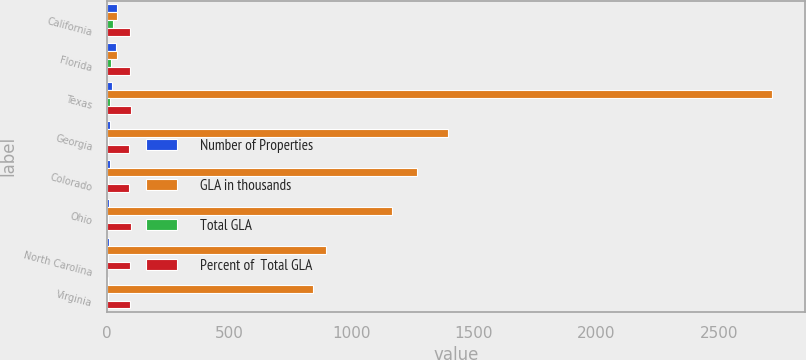<chart> <loc_0><loc_0><loc_500><loc_500><stacked_bar_chart><ecel><fcel>California<fcel>Florida<fcel>Texas<fcel>Georgia<fcel>Colorado<fcel>Ohio<fcel>North Carolina<fcel>Virginia<nl><fcel>Number of Properties<fcel>42<fcel>39<fcel>22<fcel>15<fcel>15<fcel>8<fcel>10<fcel>6<nl><fcel>GLA in thousands<fcel>40.5<fcel>40.5<fcel>2716<fcel>1392<fcel>1266<fcel>1164<fcel>895<fcel>841<nl><fcel>Total GLA<fcel>24.1<fcel>18.1<fcel>11.7<fcel>6<fcel>5.4<fcel>5<fcel>3.8<fcel>3.6<nl><fcel>Percent of  Total GLA<fcel>95.6<fcel>94.7<fcel>97.6<fcel>92.9<fcel>91.3<fcel>98.6<fcel>95.8<fcel>96.2<nl></chart> 